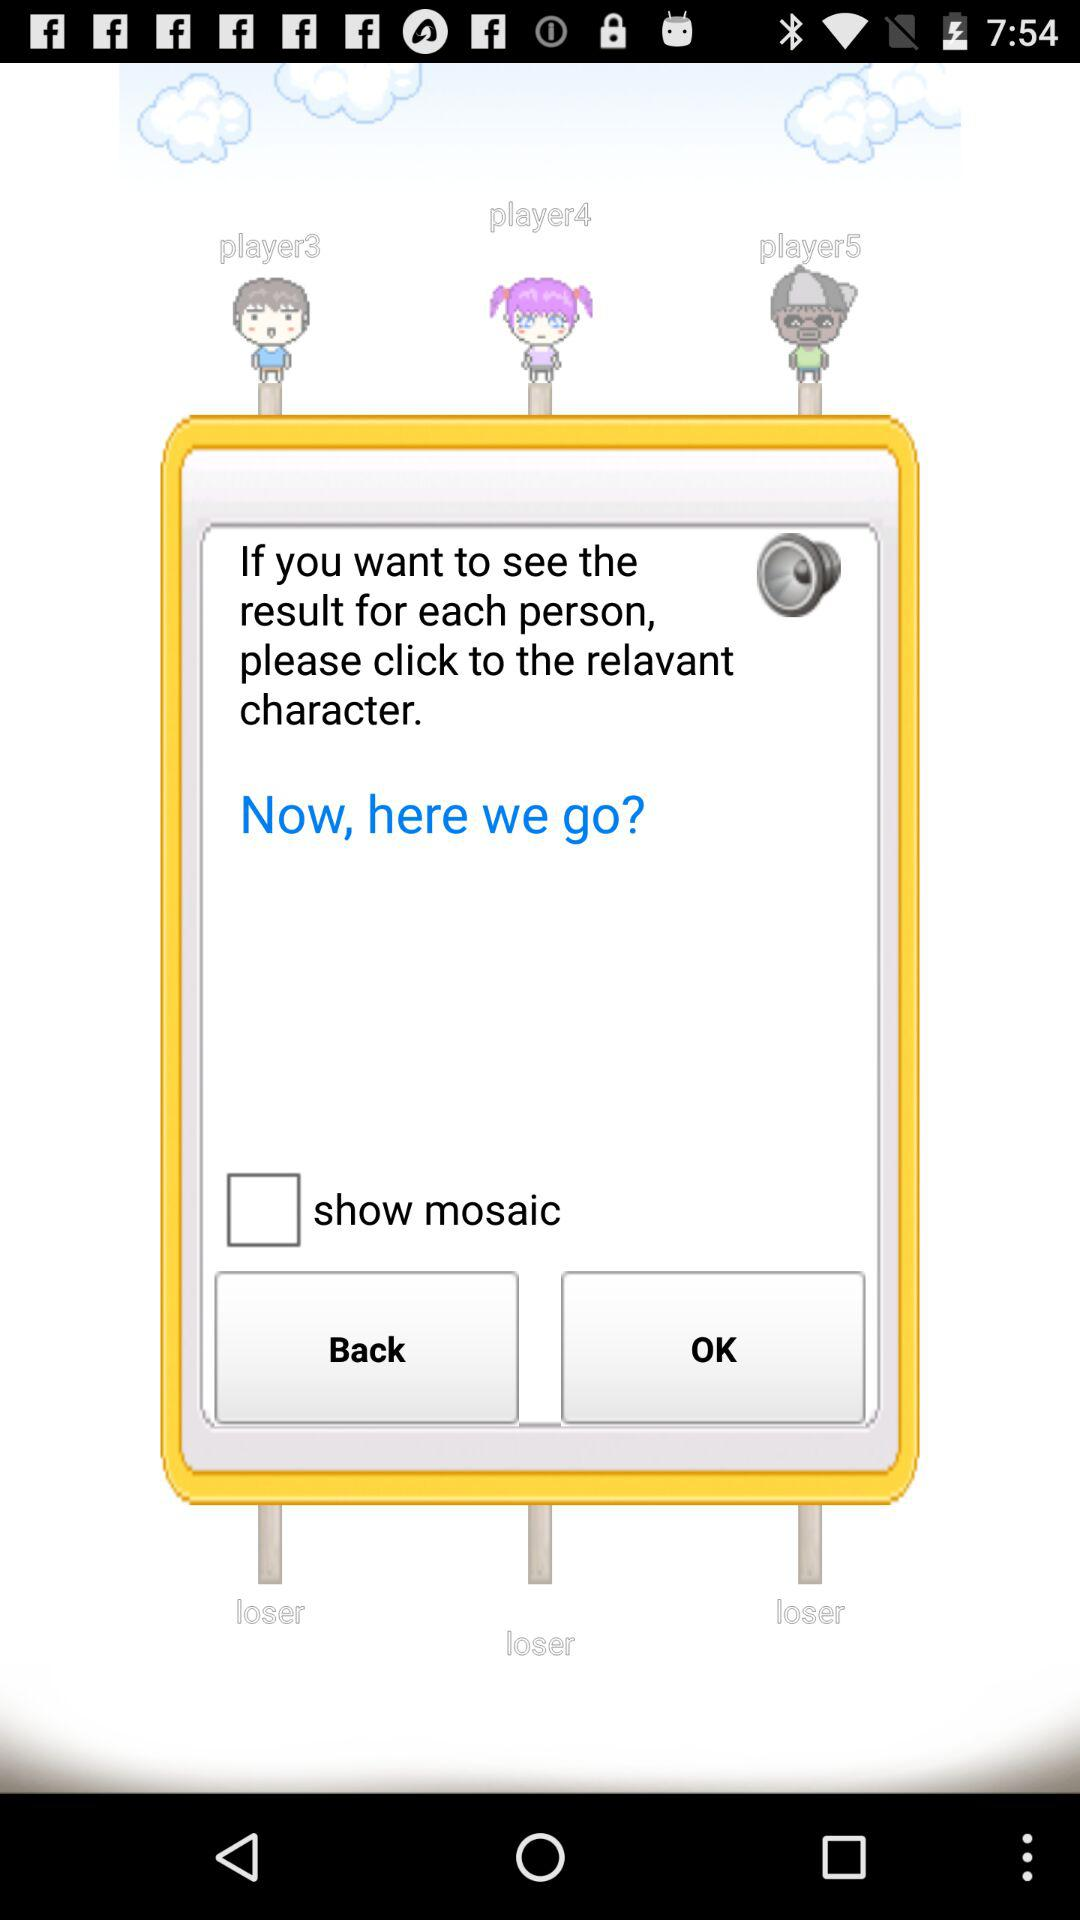How many losers are there?
Answer the question using a single word or phrase. 3 